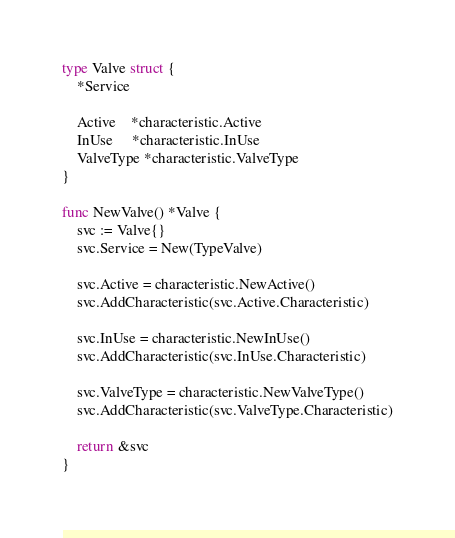<code> <loc_0><loc_0><loc_500><loc_500><_Go_>type Valve struct {
	*Service

	Active    *characteristic.Active
	InUse     *characteristic.InUse
	ValveType *characteristic.ValveType
}

func NewValve() *Valve {
	svc := Valve{}
	svc.Service = New(TypeValve)

	svc.Active = characteristic.NewActive()
	svc.AddCharacteristic(svc.Active.Characteristic)

	svc.InUse = characteristic.NewInUse()
	svc.AddCharacteristic(svc.InUse.Characteristic)

	svc.ValveType = characteristic.NewValveType()
	svc.AddCharacteristic(svc.ValveType.Characteristic)

	return &svc
}
</code> 